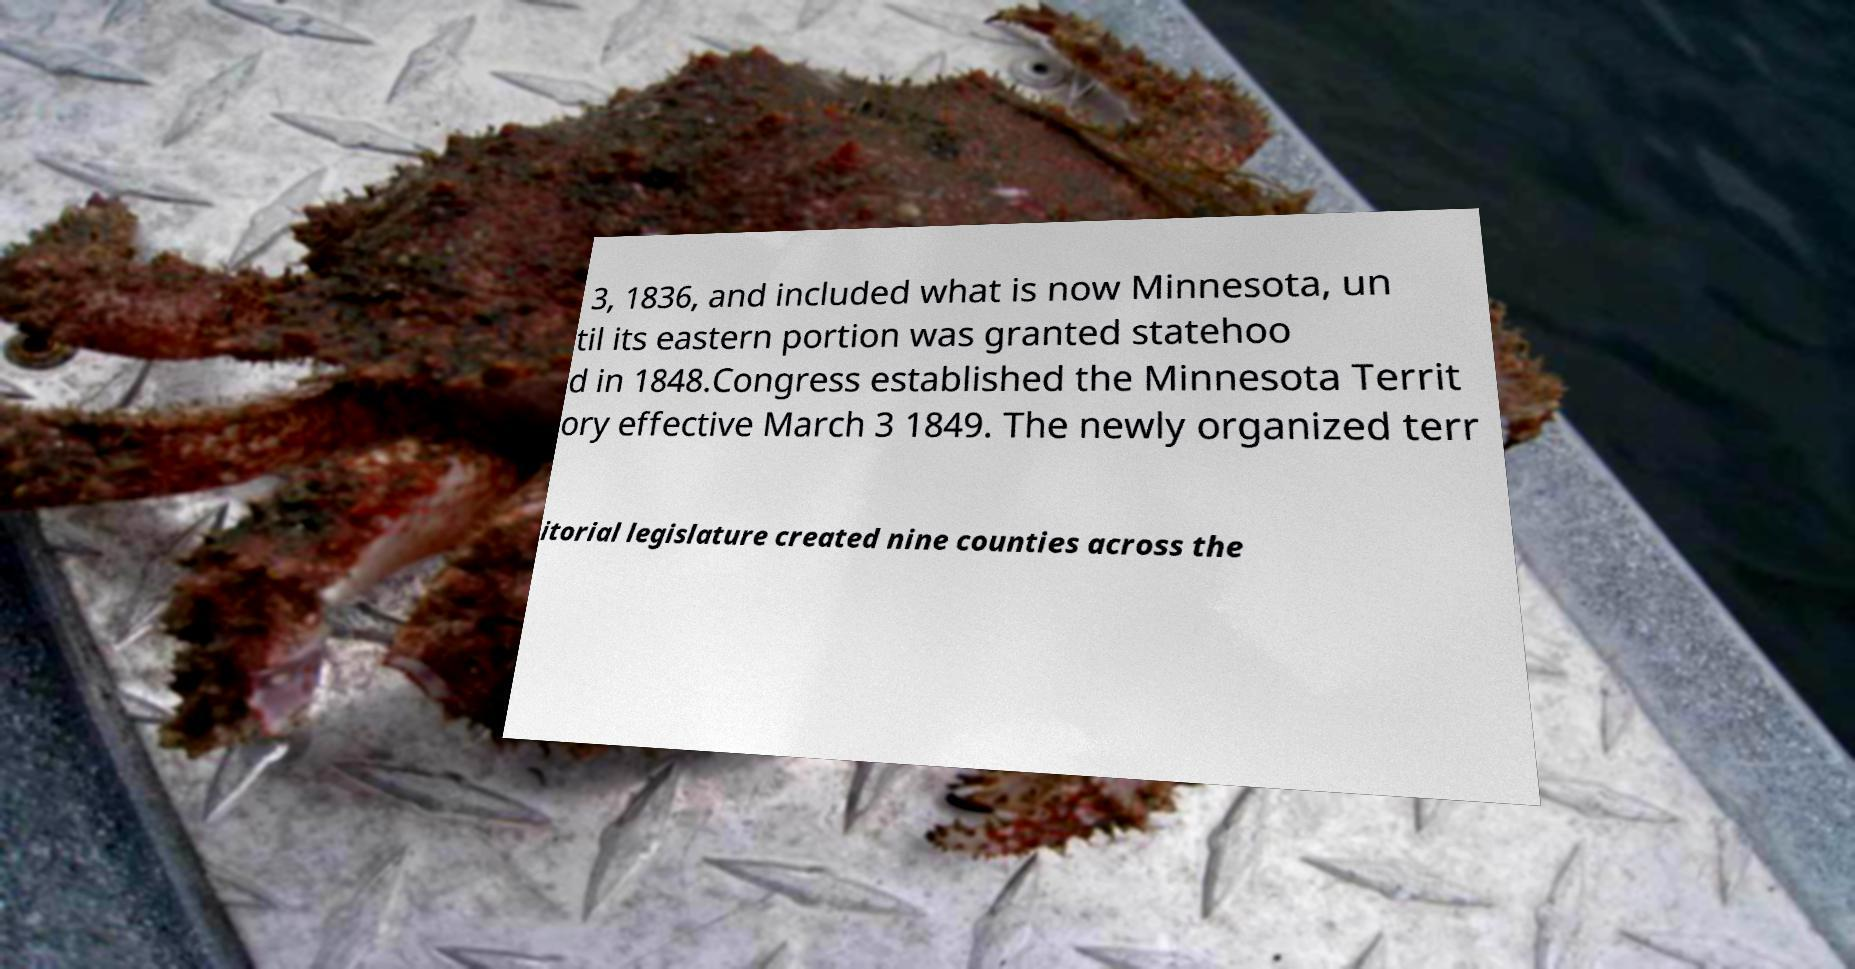Can you read and provide the text displayed in the image?This photo seems to have some interesting text. Can you extract and type it out for me? 3, 1836, and included what is now Minnesota, un til its eastern portion was granted statehoo d in 1848.Congress established the Minnesota Territ ory effective March 3 1849. The newly organized terr itorial legislature created nine counties across the 